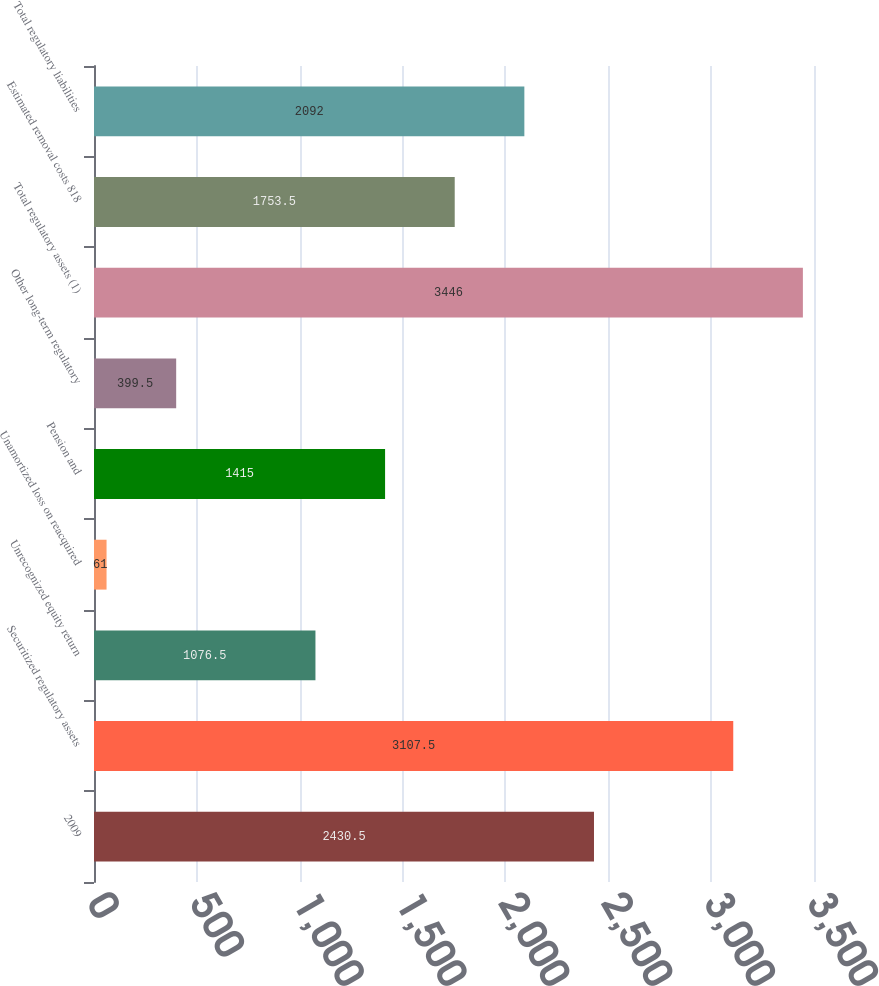Convert chart to OTSL. <chart><loc_0><loc_0><loc_500><loc_500><bar_chart><fcel>2009<fcel>Securitized regulatory assets<fcel>Unrecognized equity return<fcel>Unamortized loss on reacquired<fcel>Pension and<fcel>Other long-term regulatory<fcel>Total regulatory assets (1)<fcel>Estimated removal costs 818<fcel>Total regulatory liabilities<nl><fcel>2430.5<fcel>3107.5<fcel>1076.5<fcel>61<fcel>1415<fcel>399.5<fcel>3446<fcel>1753.5<fcel>2092<nl></chart> 